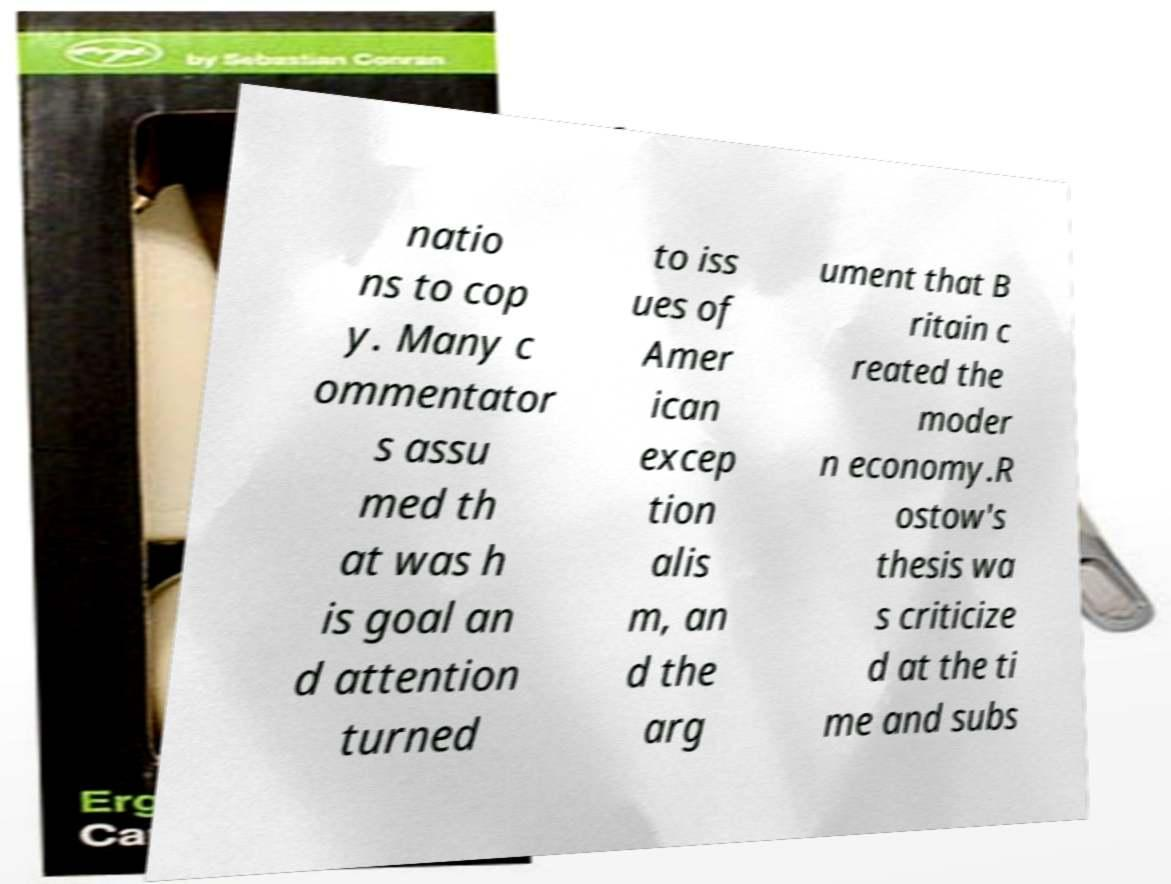Can you read and provide the text displayed in the image?This photo seems to have some interesting text. Can you extract and type it out for me? natio ns to cop y. Many c ommentator s assu med th at was h is goal an d attention turned to iss ues of Amer ican excep tion alis m, an d the arg ument that B ritain c reated the moder n economy.R ostow's thesis wa s criticize d at the ti me and subs 